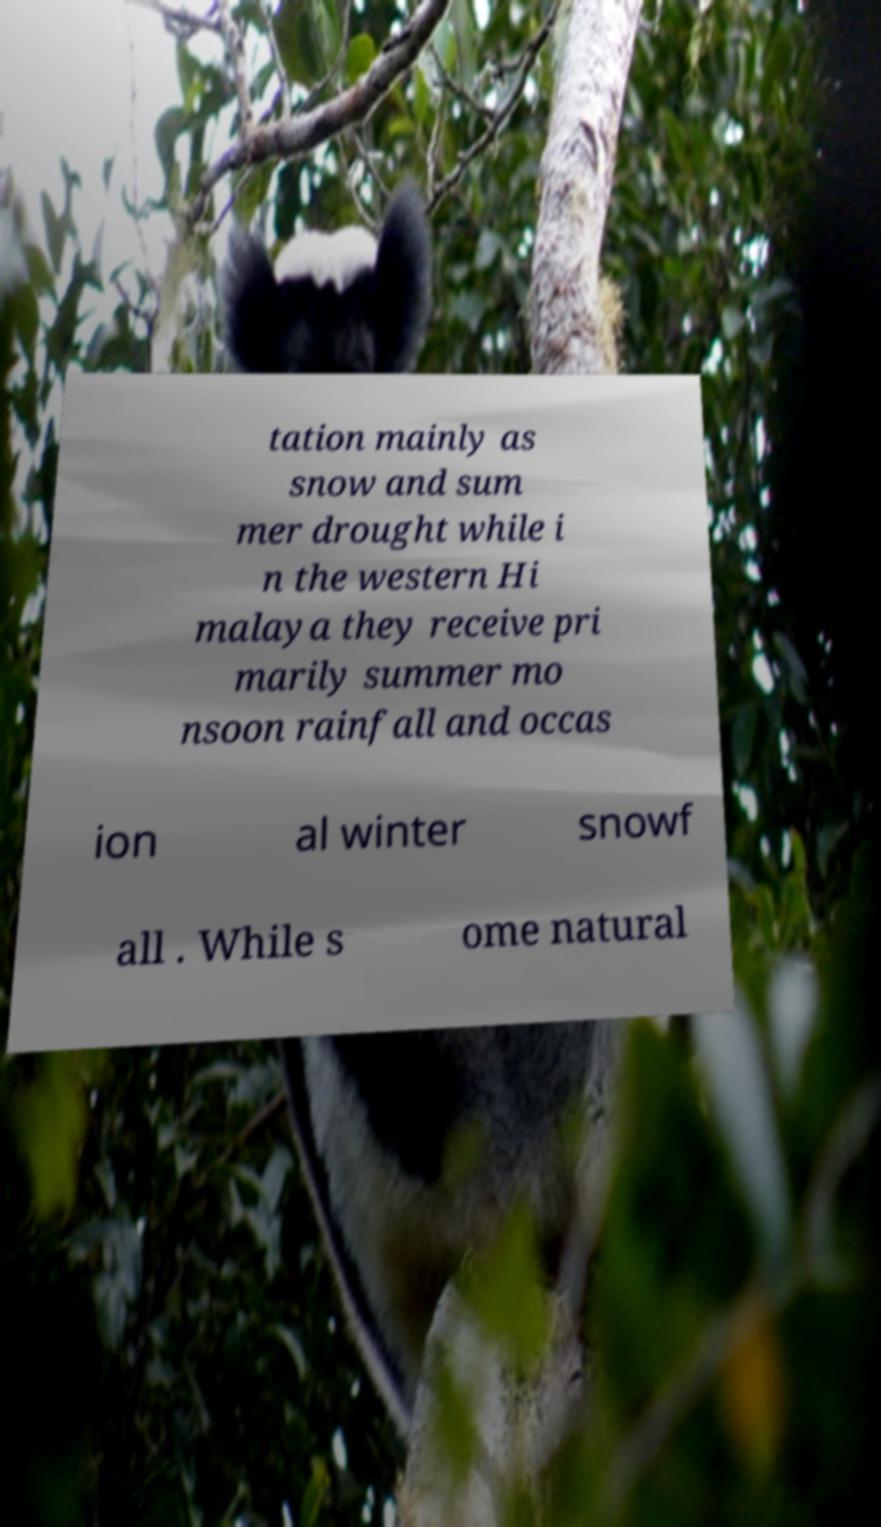Can you read and provide the text displayed in the image?This photo seems to have some interesting text. Can you extract and type it out for me? tation mainly as snow and sum mer drought while i n the western Hi malaya they receive pri marily summer mo nsoon rainfall and occas ion al winter snowf all . While s ome natural 